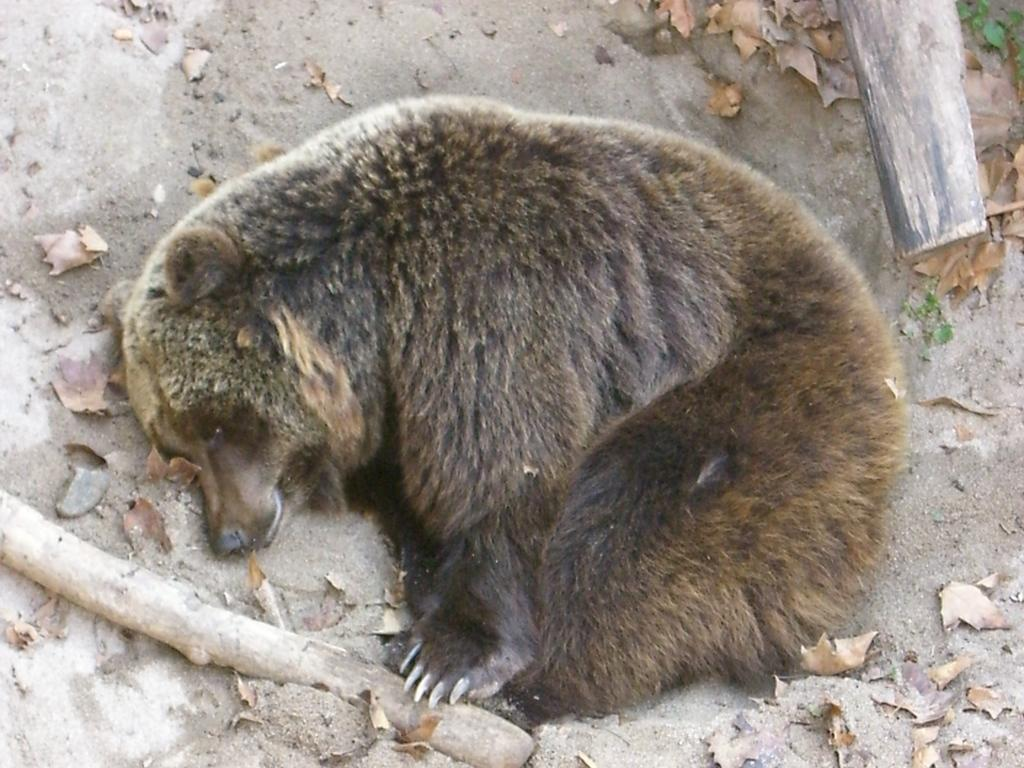What animal can be seen lying on the sand in the image? There is a bear lying on the sand in the image. What type of natural material is present in the image? Dry leaves are present in the image. What type of object made of wood can be seen in the image? Wooden sticks are visible in the image. How many kittens are playing on the bridge in the image? There are no kittens or bridge present in the image. What type of riddle can be solved by looking at the image? There is no riddle present in the image, so it cannot be solved by looking at it. 